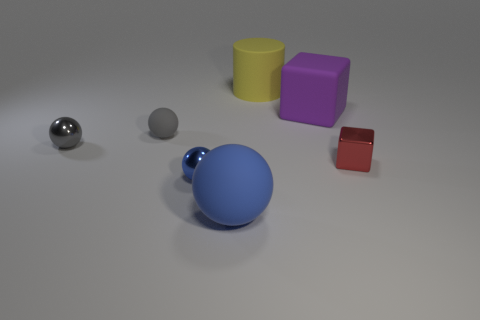There is a blue object that is the same size as the red metal object; what is its material?
Offer a very short reply. Metal. What number of green things are large cylinders or small spheres?
Make the answer very short. 0. There is a thing that is both in front of the tiny metallic cube and to the left of the large blue matte thing; what color is it?
Make the answer very short. Blue. Do the big thing that is on the left side of the large yellow cylinder and the small thing that is on the right side of the tiny blue metal sphere have the same material?
Provide a succinct answer. No. Is the number of big matte cylinders to the left of the large yellow rubber cylinder greater than the number of tiny red things behind the tiny gray metal sphere?
Keep it short and to the point. No. What is the shape of the yellow matte object that is the same size as the purple matte thing?
Offer a terse response. Cylinder. What number of objects are either tiny balls or spheres on the right side of the gray rubber thing?
Provide a short and direct response. 4. Is the color of the large ball the same as the big cube?
Ensure brevity in your answer.  No. There is a yellow rubber object; how many big things are left of it?
Your answer should be very brief. 1. What color is the other small thing that is made of the same material as the purple thing?
Your answer should be compact. Gray. 